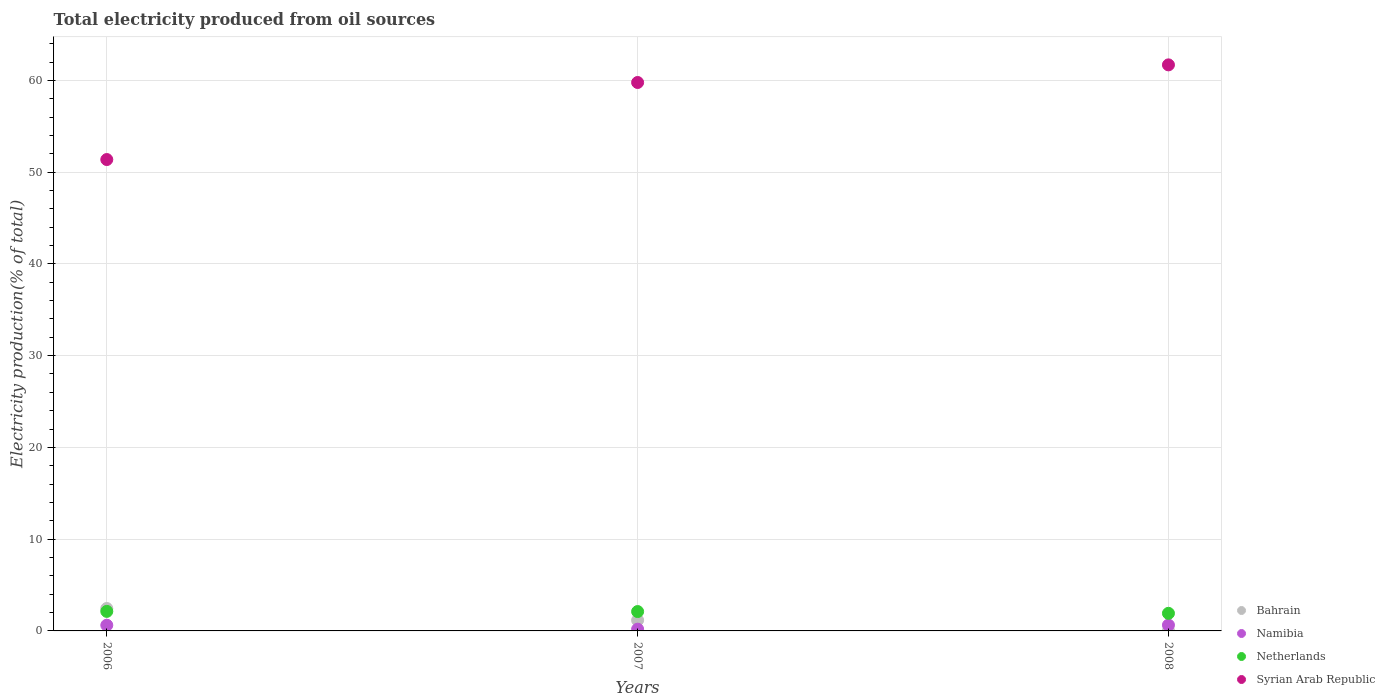How many different coloured dotlines are there?
Your response must be concise. 4. What is the total electricity produced in Namibia in 2006?
Give a very brief answer. 0.62. Across all years, what is the maximum total electricity produced in Syrian Arab Republic?
Provide a succinct answer. 61.69. Across all years, what is the minimum total electricity produced in Bahrain?
Provide a succinct answer. 0.02. In which year was the total electricity produced in Netherlands minimum?
Provide a short and direct response. 2008. What is the total total electricity produced in Syrian Arab Republic in the graph?
Offer a very short reply. 172.83. What is the difference between the total electricity produced in Bahrain in 2006 and that in 2008?
Make the answer very short. 2.42. What is the difference between the total electricity produced in Syrian Arab Republic in 2006 and the total electricity produced in Namibia in 2007?
Keep it short and to the point. 51.18. What is the average total electricity produced in Bahrain per year?
Provide a short and direct response. 1.21. In the year 2007, what is the difference between the total electricity produced in Syrian Arab Republic and total electricity produced in Netherlands?
Provide a succinct answer. 57.66. What is the ratio of the total electricity produced in Netherlands in 2006 to that in 2007?
Your answer should be very brief. 1.01. Is the difference between the total electricity produced in Syrian Arab Republic in 2007 and 2008 greater than the difference between the total electricity produced in Netherlands in 2007 and 2008?
Offer a very short reply. No. What is the difference between the highest and the second highest total electricity produced in Bahrain?
Your response must be concise. 1.28. What is the difference between the highest and the lowest total electricity produced in Bahrain?
Offer a very short reply. 2.42. Is it the case that in every year, the sum of the total electricity produced in Netherlands and total electricity produced in Bahrain  is greater than the sum of total electricity produced in Syrian Arab Republic and total electricity produced in Namibia?
Give a very brief answer. No. Is it the case that in every year, the sum of the total electricity produced in Netherlands and total electricity produced in Bahrain  is greater than the total electricity produced in Namibia?
Provide a succinct answer. Yes. Does the total electricity produced in Netherlands monotonically increase over the years?
Offer a very short reply. No. Is the total electricity produced in Bahrain strictly less than the total electricity produced in Syrian Arab Republic over the years?
Give a very brief answer. Yes. How many dotlines are there?
Make the answer very short. 4. Are the values on the major ticks of Y-axis written in scientific E-notation?
Your response must be concise. No. Does the graph contain any zero values?
Make the answer very short. No. Does the graph contain grids?
Your answer should be compact. Yes. How many legend labels are there?
Give a very brief answer. 4. How are the legend labels stacked?
Your response must be concise. Vertical. What is the title of the graph?
Provide a short and direct response. Total electricity produced from oil sources. What is the label or title of the X-axis?
Provide a short and direct response. Years. What is the Electricity production(% of total) of Bahrain in 2006?
Ensure brevity in your answer.  2.44. What is the Electricity production(% of total) of Namibia in 2006?
Give a very brief answer. 0.62. What is the Electricity production(% of total) in Netherlands in 2006?
Your response must be concise. 2.13. What is the Electricity production(% of total) in Syrian Arab Republic in 2006?
Provide a short and direct response. 51.37. What is the Electricity production(% of total) in Bahrain in 2007?
Make the answer very short. 1.16. What is the Electricity production(% of total) of Namibia in 2007?
Offer a terse response. 0.19. What is the Electricity production(% of total) in Netherlands in 2007?
Give a very brief answer. 2.11. What is the Electricity production(% of total) in Syrian Arab Republic in 2007?
Provide a short and direct response. 59.77. What is the Electricity production(% of total) in Bahrain in 2008?
Your answer should be compact. 0.02. What is the Electricity production(% of total) of Namibia in 2008?
Ensure brevity in your answer.  0.64. What is the Electricity production(% of total) of Netherlands in 2008?
Provide a short and direct response. 1.92. What is the Electricity production(% of total) of Syrian Arab Republic in 2008?
Your answer should be very brief. 61.69. Across all years, what is the maximum Electricity production(% of total) in Bahrain?
Provide a succinct answer. 2.44. Across all years, what is the maximum Electricity production(% of total) of Namibia?
Your answer should be very brief. 0.64. Across all years, what is the maximum Electricity production(% of total) in Netherlands?
Offer a very short reply. 2.13. Across all years, what is the maximum Electricity production(% of total) of Syrian Arab Republic?
Offer a very short reply. 61.69. Across all years, what is the minimum Electricity production(% of total) of Bahrain?
Provide a succinct answer. 0.02. Across all years, what is the minimum Electricity production(% of total) in Namibia?
Offer a terse response. 0.19. Across all years, what is the minimum Electricity production(% of total) of Netherlands?
Make the answer very short. 1.92. Across all years, what is the minimum Electricity production(% of total) in Syrian Arab Republic?
Provide a short and direct response. 51.37. What is the total Electricity production(% of total) of Bahrain in the graph?
Your response must be concise. 3.63. What is the total Electricity production(% of total) of Namibia in the graph?
Make the answer very short. 1.45. What is the total Electricity production(% of total) of Netherlands in the graph?
Your answer should be compact. 6.16. What is the total Electricity production(% of total) of Syrian Arab Republic in the graph?
Provide a succinct answer. 172.83. What is the difference between the Electricity production(% of total) of Bahrain in 2006 and that in 2007?
Offer a terse response. 1.28. What is the difference between the Electricity production(% of total) in Namibia in 2006 and that in 2007?
Give a very brief answer. 0.43. What is the difference between the Electricity production(% of total) in Netherlands in 2006 and that in 2007?
Ensure brevity in your answer.  0.02. What is the difference between the Electricity production(% of total) in Syrian Arab Republic in 2006 and that in 2007?
Ensure brevity in your answer.  -8.4. What is the difference between the Electricity production(% of total) in Bahrain in 2006 and that in 2008?
Your response must be concise. 2.42. What is the difference between the Electricity production(% of total) in Namibia in 2006 and that in 2008?
Provide a succinct answer. -0.01. What is the difference between the Electricity production(% of total) of Netherlands in 2006 and that in 2008?
Give a very brief answer. 0.21. What is the difference between the Electricity production(% of total) in Syrian Arab Republic in 2006 and that in 2008?
Your response must be concise. -10.32. What is the difference between the Electricity production(% of total) in Bahrain in 2007 and that in 2008?
Provide a succinct answer. 1.14. What is the difference between the Electricity production(% of total) of Namibia in 2007 and that in 2008?
Provide a succinct answer. -0.45. What is the difference between the Electricity production(% of total) in Netherlands in 2007 and that in 2008?
Your answer should be very brief. 0.19. What is the difference between the Electricity production(% of total) of Syrian Arab Republic in 2007 and that in 2008?
Your answer should be compact. -1.92. What is the difference between the Electricity production(% of total) of Bahrain in 2006 and the Electricity production(% of total) of Namibia in 2007?
Your answer should be compact. 2.25. What is the difference between the Electricity production(% of total) in Bahrain in 2006 and the Electricity production(% of total) in Netherlands in 2007?
Offer a very short reply. 0.33. What is the difference between the Electricity production(% of total) in Bahrain in 2006 and the Electricity production(% of total) in Syrian Arab Republic in 2007?
Keep it short and to the point. -57.33. What is the difference between the Electricity production(% of total) of Namibia in 2006 and the Electricity production(% of total) of Netherlands in 2007?
Provide a succinct answer. -1.49. What is the difference between the Electricity production(% of total) in Namibia in 2006 and the Electricity production(% of total) in Syrian Arab Republic in 2007?
Your answer should be compact. -59.15. What is the difference between the Electricity production(% of total) of Netherlands in 2006 and the Electricity production(% of total) of Syrian Arab Republic in 2007?
Make the answer very short. -57.64. What is the difference between the Electricity production(% of total) in Bahrain in 2006 and the Electricity production(% of total) in Namibia in 2008?
Your answer should be compact. 1.81. What is the difference between the Electricity production(% of total) of Bahrain in 2006 and the Electricity production(% of total) of Netherlands in 2008?
Make the answer very short. 0.53. What is the difference between the Electricity production(% of total) of Bahrain in 2006 and the Electricity production(% of total) of Syrian Arab Republic in 2008?
Your response must be concise. -59.25. What is the difference between the Electricity production(% of total) of Namibia in 2006 and the Electricity production(% of total) of Netherlands in 2008?
Offer a terse response. -1.3. What is the difference between the Electricity production(% of total) in Namibia in 2006 and the Electricity production(% of total) in Syrian Arab Republic in 2008?
Keep it short and to the point. -61.07. What is the difference between the Electricity production(% of total) of Netherlands in 2006 and the Electricity production(% of total) of Syrian Arab Republic in 2008?
Your answer should be very brief. -59.56. What is the difference between the Electricity production(% of total) of Bahrain in 2007 and the Electricity production(% of total) of Namibia in 2008?
Provide a succinct answer. 0.53. What is the difference between the Electricity production(% of total) in Bahrain in 2007 and the Electricity production(% of total) in Netherlands in 2008?
Your answer should be compact. -0.75. What is the difference between the Electricity production(% of total) of Bahrain in 2007 and the Electricity production(% of total) of Syrian Arab Republic in 2008?
Offer a terse response. -60.53. What is the difference between the Electricity production(% of total) in Namibia in 2007 and the Electricity production(% of total) in Netherlands in 2008?
Keep it short and to the point. -1.73. What is the difference between the Electricity production(% of total) in Namibia in 2007 and the Electricity production(% of total) in Syrian Arab Republic in 2008?
Your answer should be very brief. -61.5. What is the difference between the Electricity production(% of total) in Netherlands in 2007 and the Electricity production(% of total) in Syrian Arab Republic in 2008?
Ensure brevity in your answer.  -59.58. What is the average Electricity production(% of total) in Bahrain per year?
Provide a succinct answer. 1.21. What is the average Electricity production(% of total) of Namibia per year?
Provide a short and direct response. 0.48. What is the average Electricity production(% of total) of Netherlands per year?
Offer a very short reply. 2.05. What is the average Electricity production(% of total) in Syrian Arab Republic per year?
Keep it short and to the point. 57.61. In the year 2006, what is the difference between the Electricity production(% of total) of Bahrain and Electricity production(% of total) of Namibia?
Offer a terse response. 1.82. In the year 2006, what is the difference between the Electricity production(% of total) of Bahrain and Electricity production(% of total) of Netherlands?
Your answer should be compact. 0.31. In the year 2006, what is the difference between the Electricity production(% of total) of Bahrain and Electricity production(% of total) of Syrian Arab Republic?
Provide a succinct answer. -48.93. In the year 2006, what is the difference between the Electricity production(% of total) in Namibia and Electricity production(% of total) in Netherlands?
Your answer should be compact. -1.51. In the year 2006, what is the difference between the Electricity production(% of total) in Namibia and Electricity production(% of total) in Syrian Arab Republic?
Ensure brevity in your answer.  -50.75. In the year 2006, what is the difference between the Electricity production(% of total) in Netherlands and Electricity production(% of total) in Syrian Arab Republic?
Your answer should be very brief. -49.24. In the year 2007, what is the difference between the Electricity production(% of total) of Bahrain and Electricity production(% of total) of Namibia?
Your answer should be compact. 0.97. In the year 2007, what is the difference between the Electricity production(% of total) of Bahrain and Electricity production(% of total) of Netherlands?
Offer a terse response. -0.95. In the year 2007, what is the difference between the Electricity production(% of total) in Bahrain and Electricity production(% of total) in Syrian Arab Republic?
Provide a succinct answer. -58.6. In the year 2007, what is the difference between the Electricity production(% of total) of Namibia and Electricity production(% of total) of Netherlands?
Your response must be concise. -1.92. In the year 2007, what is the difference between the Electricity production(% of total) in Namibia and Electricity production(% of total) in Syrian Arab Republic?
Offer a very short reply. -59.58. In the year 2007, what is the difference between the Electricity production(% of total) of Netherlands and Electricity production(% of total) of Syrian Arab Republic?
Make the answer very short. -57.66. In the year 2008, what is the difference between the Electricity production(% of total) in Bahrain and Electricity production(% of total) in Namibia?
Your response must be concise. -0.61. In the year 2008, what is the difference between the Electricity production(% of total) of Bahrain and Electricity production(% of total) of Netherlands?
Make the answer very short. -1.9. In the year 2008, what is the difference between the Electricity production(% of total) in Bahrain and Electricity production(% of total) in Syrian Arab Republic?
Offer a very short reply. -61.67. In the year 2008, what is the difference between the Electricity production(% of total) in Namibia and Electricity production(% of total) in Netherlands?
Your answer should be compact. -1.28. In the year 2008, what is the difference between the Electricity production(% of total) in Namibia and Electricity production(% of total) in Syrian Arab Republic?
Ensure brevity in your answer.  -61.05. In the year 2008, what is the difference between the Electricity production(% of total) in Netherlands and Electricity production(% of total) in Syrian Arab Republic?
Offer a very short reply. -59.77. What is the ratio of the Electricity production(% of total) in Bahrain in 2006 to that in 2007?
Offer a terse response. 2.1. What is the ratio of the Electricity production(% of total) in Namibia in 2006 to that in 2007?
Provide a succinct answer. 3.27. What is the ratio of the Electricity production(% of total) in Netherlands in 2006 to that in 2007?
Make the answer very short. 1.01. What is the ratio of the Electricity production(% of total) in Syrian Arab Republic in 2006 to that in 2007?
Provide a succinct answer. 0.86. What is the ratio of the Electricity production(% of total) of Bahrain in 2006 to that in 2008?
Offer a very short reply. 111.51. What is the ratio of the Electricity production(% of total) of Namibia in 2006 to that in 2008?
Your answer should be very brief. 0.98. What is the ratio of the Electricity production(% of total) of Netherlands in 2006 to that in 2008?
Provide a succinct answer. 1.11. What is the ratio of the Electricity production(% of total) in Syrian Arab Republic in 2006 to that in 2008?
Provide a short and direct response. 0.83. What is the ratio of the Electricity production(% of total) of Bahrain in 2007 to that in 2008?
Your answer should be very brief. 53.16. What is the ratio of the Electricity production(% of total) in Namibia in 2007 to that in 2008?
Offer a terse response. 0.3. What is the ratio of the Electricity production(% of total) of Netherlands in 2007 to that in 2008?
Keep it short and to the point. 1.1. What is the ratio of the Electricity production(% of total) of Syrian Arab Republic in 2007 to that in 2008?
Offer a very short reply. 0.97. What is the difference between the highest and the second highest Electricity production(% of total) of Bahrain?
Make the answer very short. 1.28. What is the difference between the highest and the second highest Electricity production(% of total) in Namibia?
Provide a succinct answer. 0.01. What is the difference between the highest and the second highest Electricity production(% of total) of Netherlands?
Your answer should be very brief. 0.02. What is the difference between the highest and the second highest Electricity production(% of total) of Syrian Arab Republic?
Offer a very short reply. 1.92. What is the difference between the highest and the lowest Electricity production(% of total) in Bahrain?
Your answer should be compact. 2.42. What is the difference between the highest and the lowest Electricity production(% of total) of Namibia?
Your answer should be very brief. 0.45. What is the difference between the highest and the lowest Electricity production(% of total) in Netherlands?
Give a very brief answer. 0.21. What is the difference between the highest and the lowest Electricity production(% of total) of Syrian Arab Republic?
Your answer should be very brief. 10.32. 